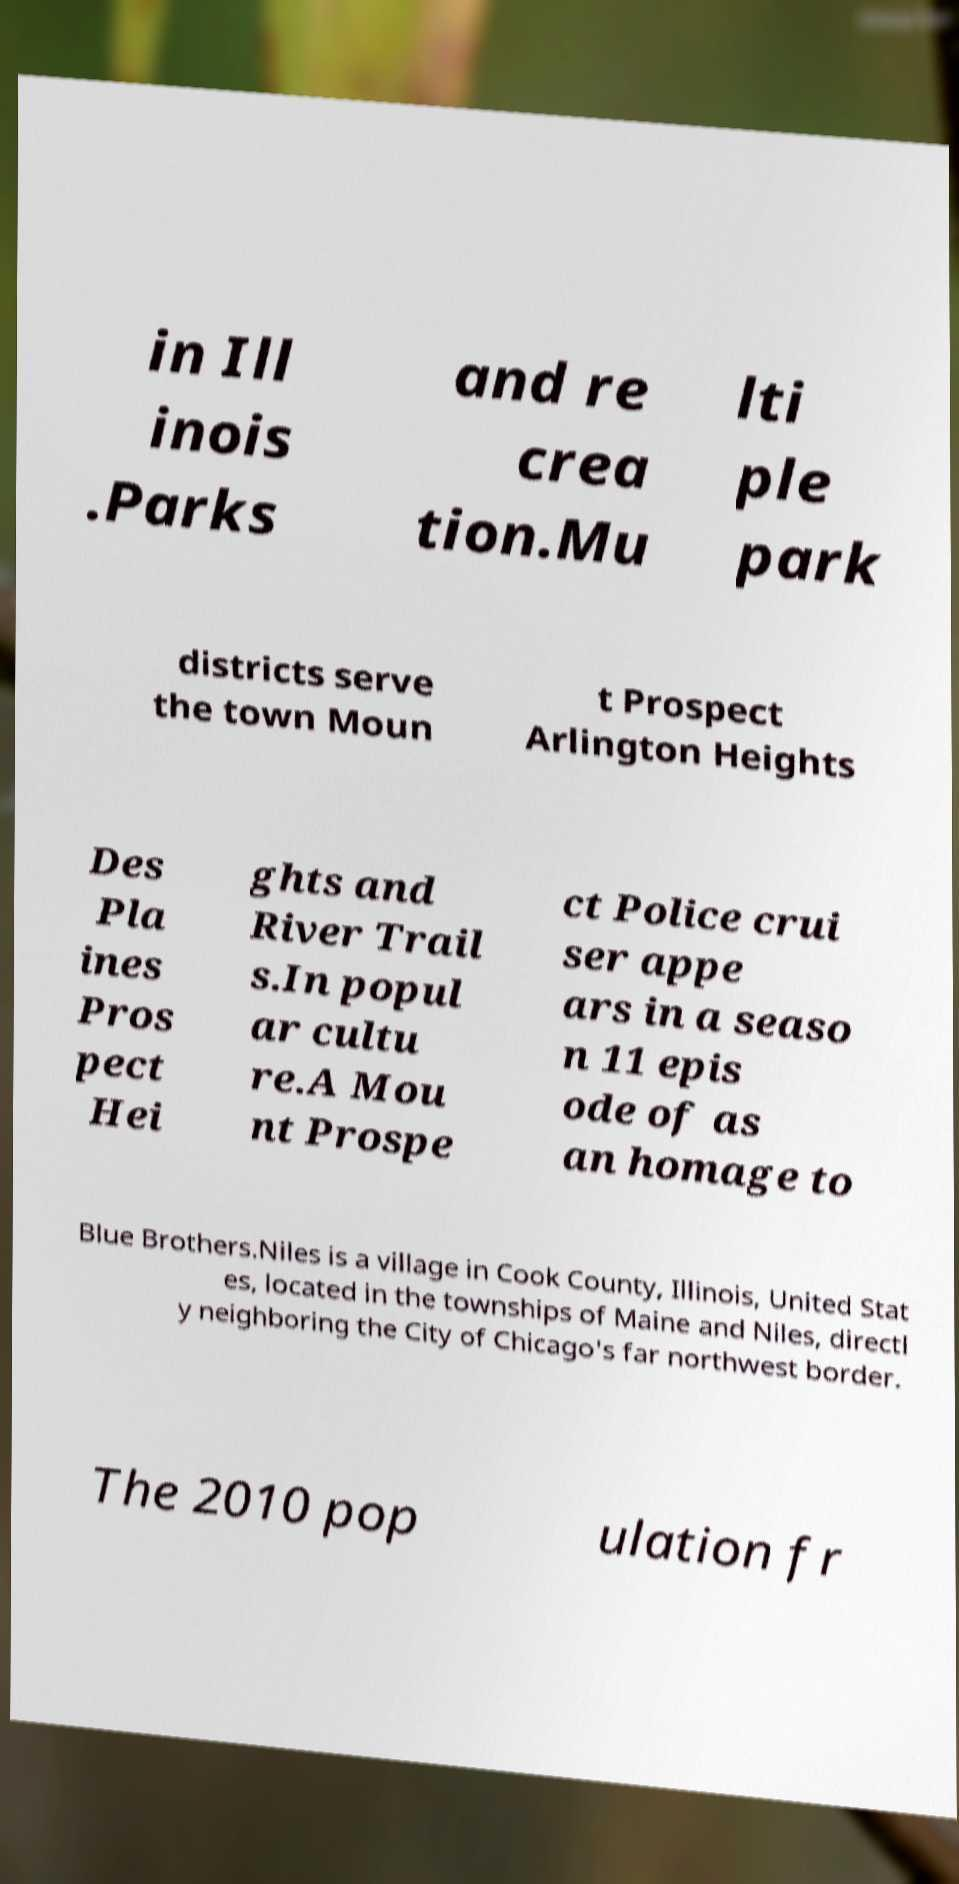Please read and relay the text visible in this image. What does it say? in Ill inois .Parks and re crea tion.Mu lti ple park districts serve the town Moun t Prospect Arlington Heights Des Pla ines Pros pect Hei ghts and River Trail s.In popul ar cultu re.A Mou nt Prospe ct Police crui ser appe ars in a seaso n 11 epis ode of as an homage to Blue Brothers.Niles is a village in Cook County, Illinois, United Stat es, located in the townships of Maine and Niles, directl y neighboring the City of Chicago's far northwest border. The 2010 pop ulation fr 